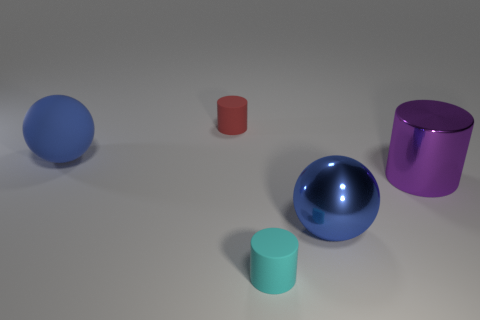Add 1 small blue cylinders. How many objects exist? 6 Subtract all balls. How many objects are left? 3 Add 3 red matte cylinders. How many red matte cylinders exist? 4 Subtract 0 brown cylinders. How many objects are left? 5 Subtract all cyan things. Subtract all tiny rubber things. How many objects are left? 2 Add 2 large purple cylinders. How many large purple cylinders are left? 3 